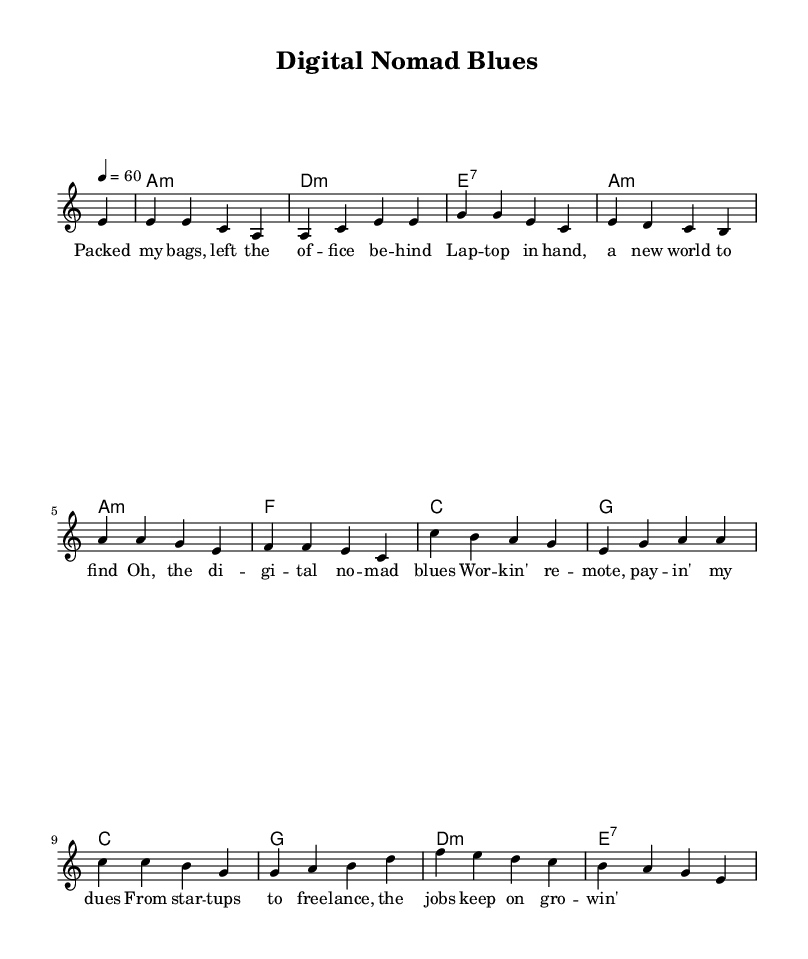What is the key signature of this music? The key signature is A minor, which has no sharps or flats. A minor is relative to C major and is indicated at the beginning of the score.
Answer: A minor What is the time signature of this music? The time signature is 4/4, which means there are four beats in each measure and the quarter note gets one beat. This is a common time signature for blues music.
Answer: 4/4 What tempo marking is indicated for this piece? The tempo marking is 60 beats per minute, which specifies the speed of the piece. It is indicated at the beginning of the score under the tempo marking.
Answer: 60 How many measures are in the melody section? The melody section contains 12 measures as indicated by the sequence of notes subdivided into groups throughout the score. Counting each complete measure gives us the total.
Answer: 12 What type of chord is used at the beginning of the harmonies? The chord at the beginning of the harmonies is an A minor chord, which is denoted as "a1:m" in the chord mode section, indicating the first chord played.
Answer: A minor What lyrical theme is featured in the first verse? The lyrical theme featured in the first verse revolves around remote work and digital nomadism, as it discusses leaving the office, exploring new worlds, and working from different locations. The lyrics express the transition to a nomadic lifestyle and its impact.
Answer: Remote work What is the rhyme scheme of the first verse? The rhyme scheme of the first verse follows an AABBA pattern, where the first two lines rhyme with each other, the next two lines form another rhyme, and the last line concludes the stanza with a different rhyme, typical in blues ballads.
Answer: AABBA 